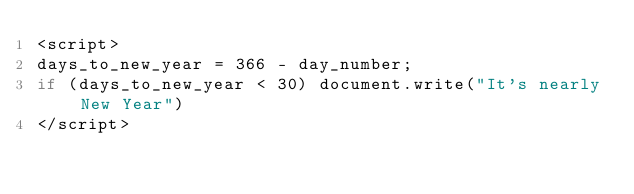Convert code to text. <code><loc_0><loc_0><loc_500><loc_500><_JavaScript_><script>
days_to_new_year = 366 - day_number;
if (days_to_new_year < 30) document.write("It's nearly New Year")
</script></code> 